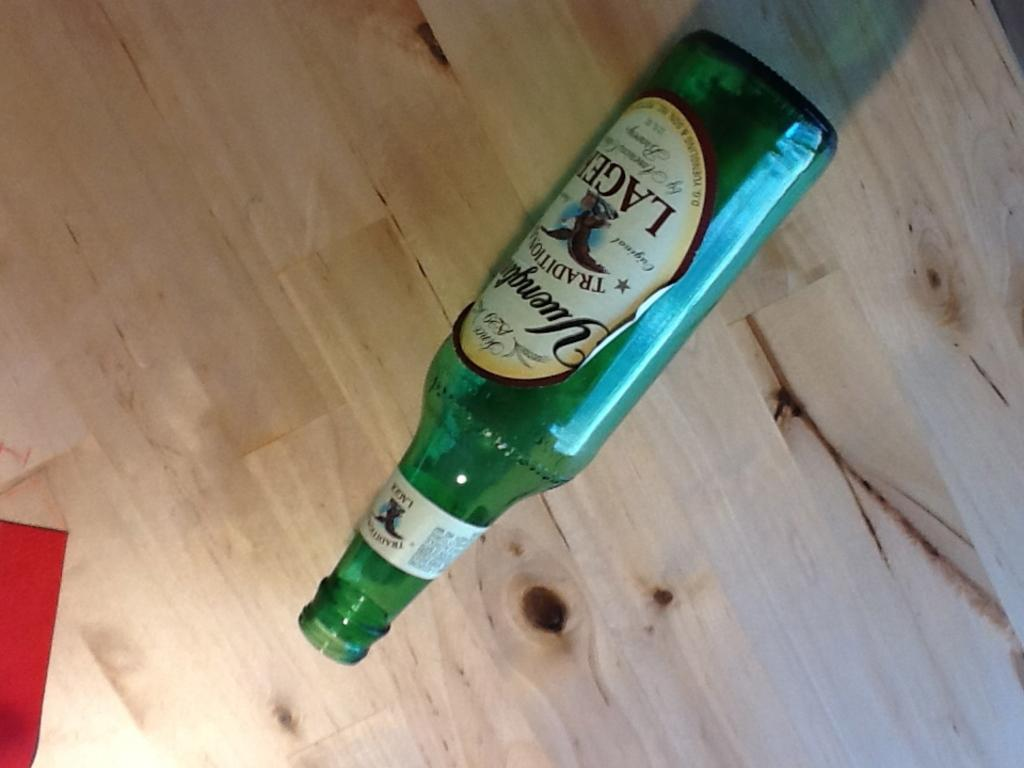What object can be seen in the image? There is a bottle in the image. What is on the bottle? The bottle has a sticker on it. Where is the bottle located? The bottle is placed on a wooden table. What color is visible on the left side of the image? There is a red color visible on the left side of the image. What type of sweater is the person wearing in the image? There is no person or sweater present in the image; it only features a bottle with a sticker on it, placed on a wooden table. 